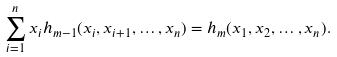Convert formula to latex. <formula><loc_0><loc_0><loc_500><loc_500>\sum _ { i = 1 } ^ { n } x _ { i } h _ { m - 1 } ( x _ { i } , x _ { i + 1 } , \dots , x _ { n } ) = h _ { m } ( x _ { 1 } , x _ { 2 } , \dots , x _ { n } ) .</formula> 